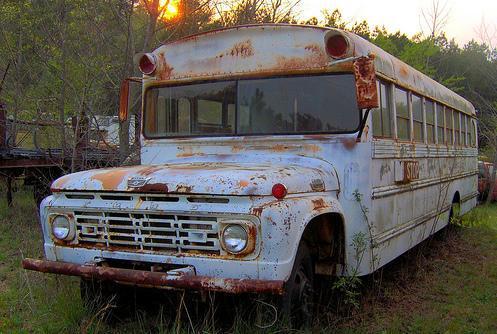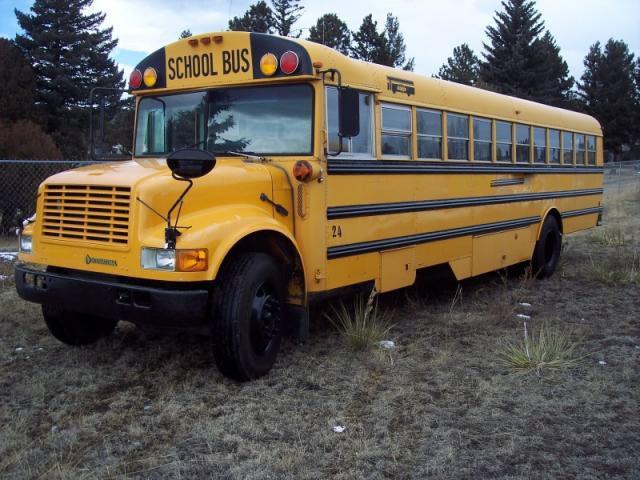The first image is the image on the left, the second image is the image on the right. Considering the images on both sides, is "The left image shows an angled, forward-facing bus with rust and other condition issues, and the right image features a leftward-angled bus in good condition." valid? Answer yes or no. Yes. The first image is the image on the left, the second image is the image on the right. Analyze the images presented: Is the assertion "There are at least 12 window on the rusted out bus." valid? Answer yes or no. Yes. 